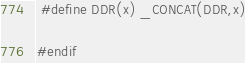<code> <loc_0><loc_0><loc_500><loc_500><_C_> #define DDR(x) _CONCAT(DDR,x)

#endif
</code> 